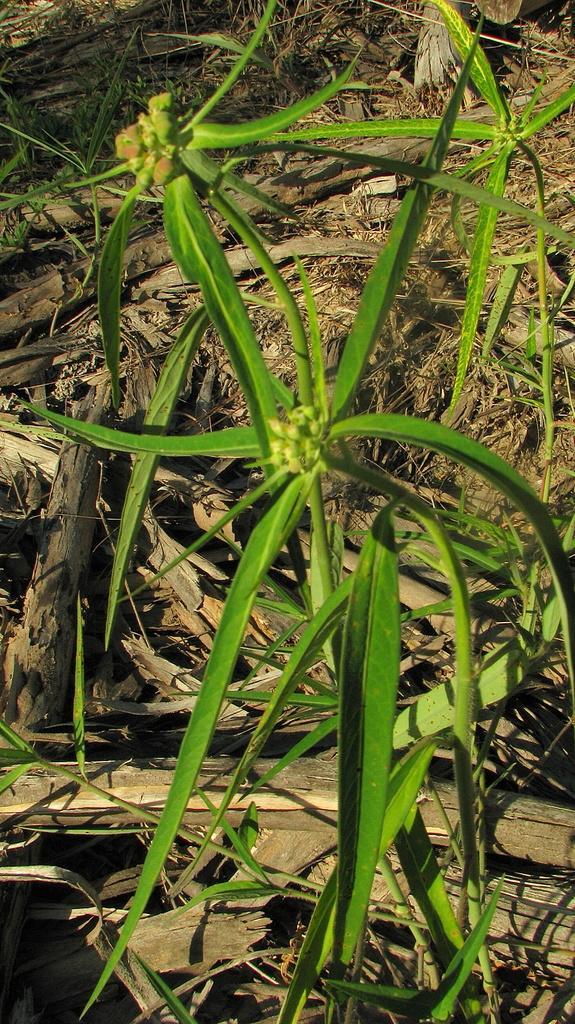How would you summarize this image in a sentence or two? In the image there are green leaves to the stems. Behind them there are dry leaves and wooden sticks are on the ground. 